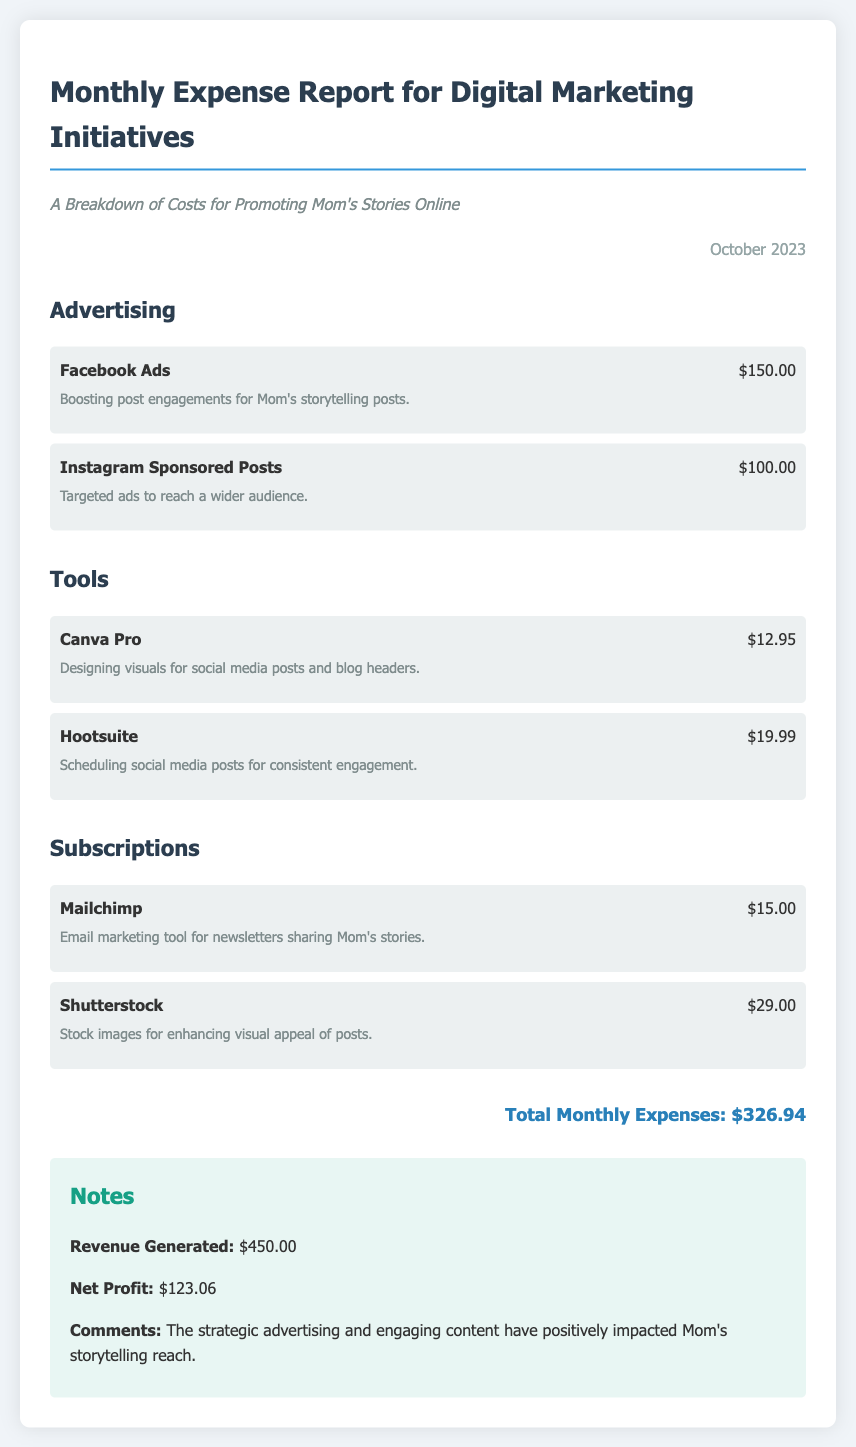What is the total amount spent on Facebook Ads? The document specifies that Facebook Ads cost $150.00.
Answer: $150.00 How much was spent on Instagram Sponsored Posts? The total cost for Instagram Sponsored Posts is listed as $100.00 in the document.
Answer: $100.00 What is the cost of Canva Pro? Canva Pro is stated to cost $12.95 in the expense report.
Answer: $12.95 What is the total monthly expense reported? The document clearly states the total monthly expenses amount to $326.94.
Answer: $326.94 What is the revenue generated reported? The revenue generated according to the notes section is $450.00.
Answer: $450.00 How much is the net profit recognized in the report? The document outlines the net profit as $123.06 in the notes section.
Answer: $123.06 What tool is used for email marketing? The document mentions Mailchimp as the email marketing tool used.
Answer: Mailchimp What category does Hootsuite fall under? Hootsuite is categorized under "Tools" in the expense report.
Answer: Tools What month does this expense report cover? The expense report is for October 2023, as mentioned at the top of the document.
Answer: October 2023 